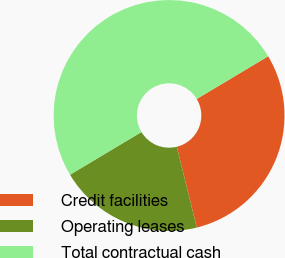Convert chart. <chart><loc_0><loc_0><loc_500><loc_500><pie_chart><fcel>Credit facilities<fcel>Operating leases<fcel>Total contractual cash<nl><fcel>29.72%<fcel>20.28%<fcel>50.0%<nl></chart> 